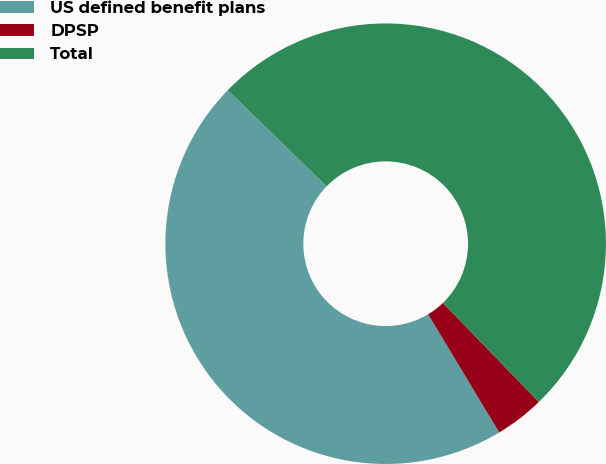Convert chart to OTSL. <chart><loc_0><loc_0><loc_500><loc_500><pie_chart><fcel>US defined benefit plans<fcel>DPSP<fcel>Total<nl><fcel>45.89%<fcel>3.63%<fcel>50.48%<nl></chart> 